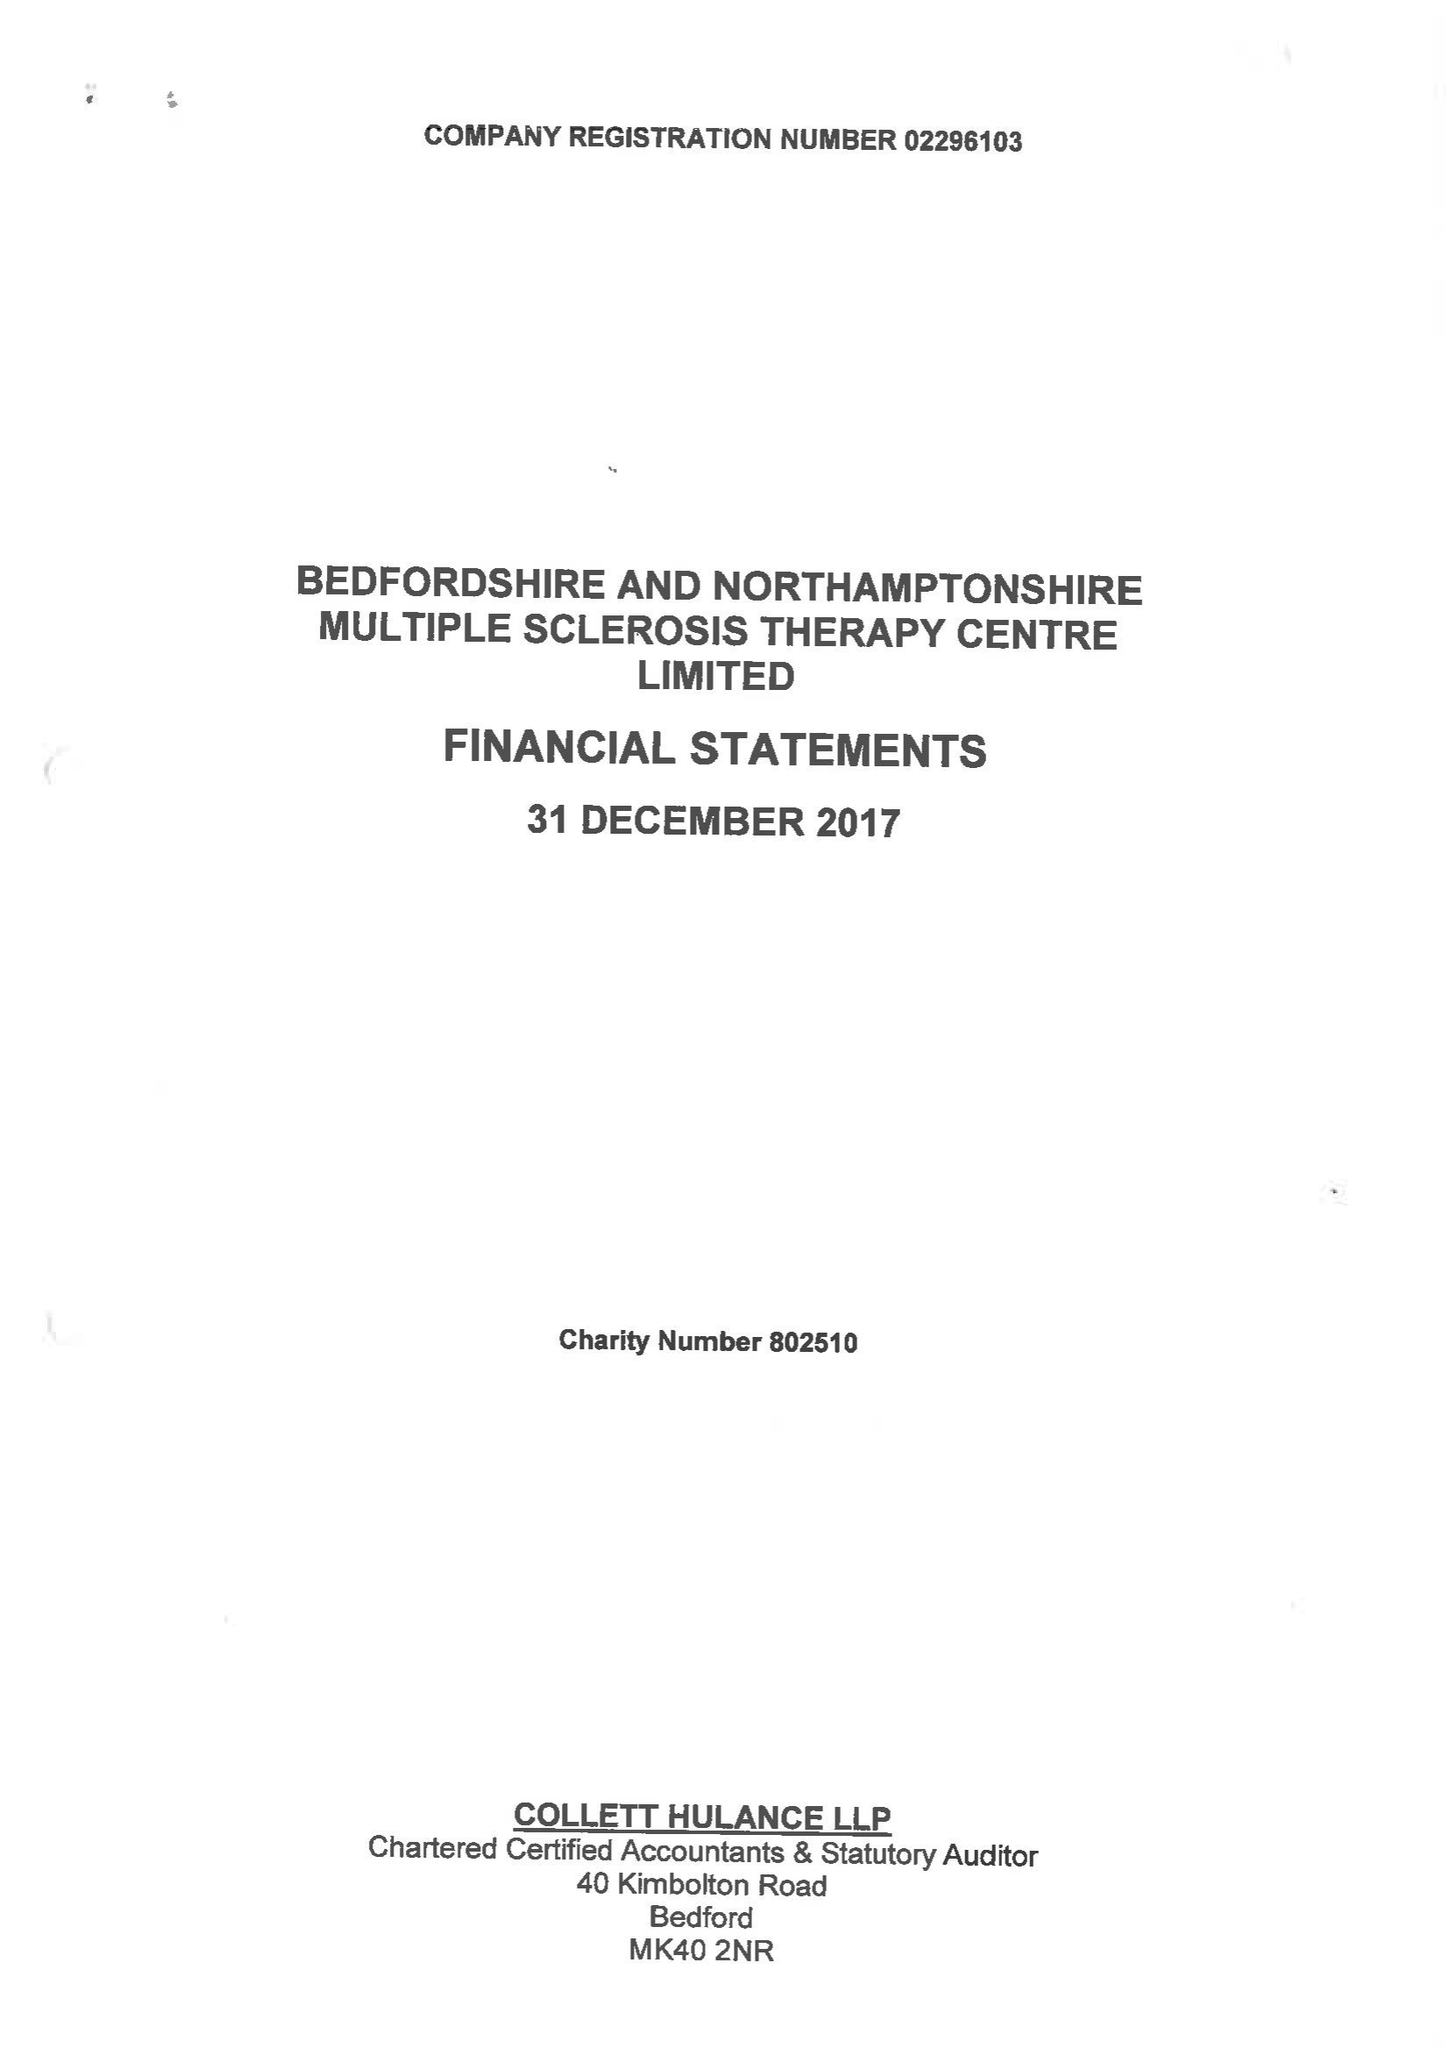What is the value for the charity_name?
Answer the question using a single word or phrase. Bedfordshire and Northamptonshire Multiple Sclerosis Therapy Centre Ltd. 